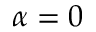<formula> <loc_0><loc_0><loc_500><loc_500>\alpha = 0</formula> 